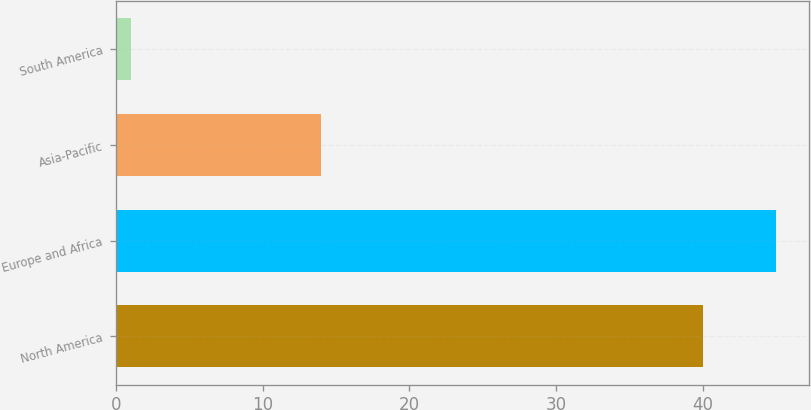<chart> <loc_0><loc_0><loc_500><loc_500><bar_chart><fcel>North America<fcel>Europe and Africa<fcel>Asia-Pacific<fcel>South America<nl><fcel>40<fcel>45<fcel>14<fcel>1<nl></chart> 